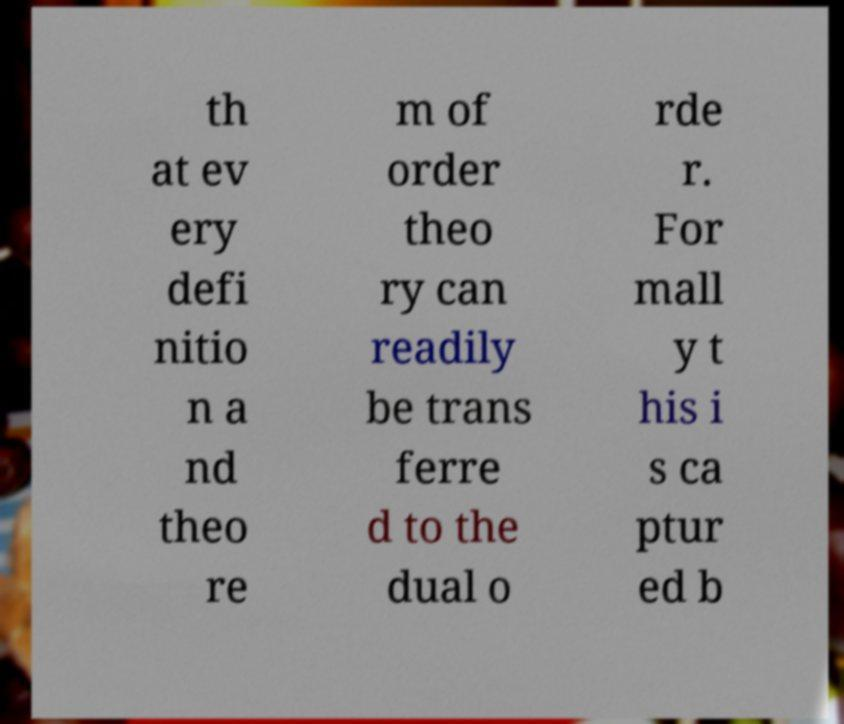Can you read and provide the text displayed in the image?This photo seems to have some interesting text. Can you extract and type it out for me? th at ev ery defi nitio n a nd theo re m of order theo ry can readily be trans ferre d to the dual o rde r. For mall y t his i s ca ptur ed b 